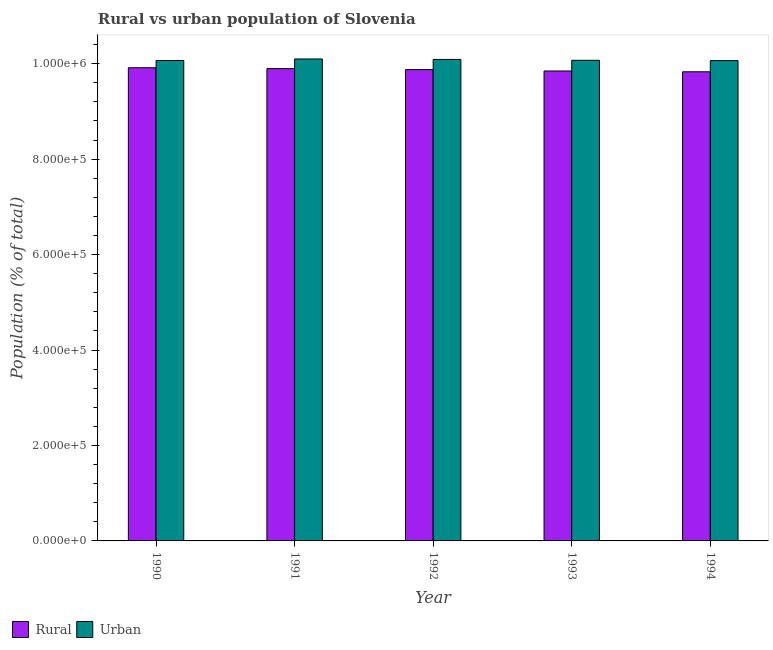How many different coloured bars are there?
Keep it short and to the point. 2. What is the label of the 4th group of bars from the left?
Your response must be concise. 1993. What is the rural population density in 1990?
Offer a terse response. 9.91e+05. Across all years, what is the maximum urban population density?
Give a very brief answer. 1.01e+06. Across all years, what is the minimum urban population density?
Provide a short and direct response. 1.01e+06. In which year was the rural population density maximum?
Offer a terse response. 1990. In which year was the rural population density minimum?
Provide a succinct answer. 1994. What is the total urban population density in the graph?
Your answer should be compact. 5.04e+06. What is the difference between the rural population density in 1991 and that in 1994?
Offer a terse response. 6573. What is the difference between the rural population density in 1992 and the urban population density in 1994?
Ensure brevity in your answer.  4584. What is the average urban population density per year?
Offer a terse response. 1.01e+06. What is the ratio of the urban population density in 1991 to that in 1993?
Give a very brief answer. 1. Is the difference between the rural population density in 1991 and 1994 greater than the difference between the urban population density in 1991 and 1994?
Your answer should be very brief. No. What is the difference between the highest and the second highest urban population density?
Keep it short and to the point. 942. What is the difference between the highest and the lowest rural population density?
Ensure brevity in your answer.  8483. In how many years, is the urban population density greater than the average urban population density taken over all years?
Your answer should be very brief. 2. Is the sum of the rural population density in 1990 and 1994 greater than the maximum urban population density across all years?
Your response must be concise. Yes. What does the 1st bar from the left in 1994 represents?
Offer a very short reply. Rural. What does the 2nd bar from the right in 1994 represents?
Offer a terse response. Rural. Are all the bars in the graph horizontal?
Keep it short and to the point. No. How many years are there in the graph?
Ensure brevity in your answer.  5. What is the difference between two consecutive major ticks on the Y-axis?
Offer a terse response. 2.00e+05. Does the graph contain any zero values?
Your answer should be very brief. No. Does the graph contain grids?
Provide a succinct answer. No. Where does the legend appear in the graph?
Offer a terse response. Bottom left. How are the legend labels stacked?
Ensure brevity in your answer.  Horizontal. What is the title of the graph?
Ensure brevity in your answer.  Rural vs urban population of Slovenia. What is the label or title of the Y-axis?
Provide a succinct answer. Population (% of total). What is the Population (% of total) of Rural in 1990?
Your answer should be compact. 9.91e+05. What is the Population (% of total) of Urban in 1990?
Offer a very short reply. 1.01e+06. What is the Population (% of total) of Rural in 1991?
Offer a terse response. 9.90e+05. What is the Population (% of total) of Urban in 1991?
Provide a succinct answer. 1.01e+06. What is the Population (% of total) in Rural in 1992?
Give a very brief answer. 9.88e+05. What is the Population (% of total) of Urban in 1992?
Ensure brevity in your answer.  1.01e+06. What is the Population (% of total) of Rural in 1993?
Provide a short and direct response. 9.85e+05. What is the Population (% of total) in Urban in 1993?
Your response must be concise. 1.01e+06. What is the Population (% of total) in Rural in 1994?
Your answer should be very brief. 9.83e+05. What is the Population (% of total) of Urban in 1994?
Offer a very short reply. 1.01e+06. Across all years, what is the maximum Population (% of total) of Rural?
Make the answer very short. 9.91e+05. Across all years, what is the maximum Population (% of total) in Urban?
Make the answer very short. 1.01e+06. Across all years, what is the minimum Population (% of total) in Rural?
Offer a terse response. 9.83e+05. Across all years, what is the minimum Population (% of total) in Urban?
Provide a succinct answer. 1.01e+06. What is the total Population (% of total) of Rural in the graph?
Your response must be concise. 4.94e+06. What is the total Population (% of total) of Urban in the graph?
Offer a terse response. 5.04e+06. What is the difference between the Population (% of total) in Rural in 1990 and that in 1991?
Keep it short and to the point. 1910. What is the difference between the Population (% of total) of Urban in 1990 and that in 1991?
Your response must be concise. -3178. What is the difference between the Population (% of total) of Rural in 1990 and that in 1992?
Offer a very short reply. 3899. What is the difference between the Population (% of total) in Urban in 1990 and that in 1992?
Keep it short and to the point. -2236. What is the difference between the Population (% of total) of Rural in 1990 and that in 1993?
Provide a succinct answer. 6788. What is the difference between the Population (% of total) of Urban in 1990 and that in 1993?
Give a very brief answer. -373. What is the difference between the Population (% of total) of Rural in 1990 and that in 1994?
Your answer should be compact. 8483. What is the difference between the Population (% of total) in Urban in 1990 and that in 1994?
Offer a very short reply. 235. What is the difference between the Population (% of total) in Rural in 1991 and that in 1992?
Your answer should be compact. 1989. What is the difference between the Population (% of total) in Urban in 1991 and that in 1992?
Your response must be concise. 942. What is the difference between the Population (% of total) of Rural in 1991 and that in 1993?
Offer a very short reply. 4878. What is the difference between the Population (% of total) of Urban in 1991 and that in 1993?
Your answer should be compact. 2805. What is the difference between the Population (% of total) of Rural in 1991 and that in 1994?
Your response must be concise. 6573. What is the difference between the Population (% of total) of Urban in 1991 and that in 1994?
Your response must be concise. 3413. What is the difference between the Population (% of total) in Rural in 1992 and that in 1993?
Your response must be concise. 2889. What is the difference between the Population (% of total) of Urban in 1992 and that in 1993?
Your answer should be very brief. 1863. What is the difference between the Population (% of total) of Rural in 1992 and that in 1994?
Provide a succinct answer. 4584. What is the difference between the Population (% of total) in Urban in 1992 and that in 1994?
Ensure brevity in your answer.  2471. What is the difference between the Population (% of total) of Rural in 1993 and that in 1994?
Ensure brevity in your answer.  1695. What is the difference between the Population (% of total) of Urban in 1993 and that in 1994?
Provide a succinct answer. 608. What is the difference between the Population (% of total) of Rural in 1990 and the Population (% of total) of Urban in 1991?
Your response must be concise. -1.84e+04. What is the difference between the Population (% of total) of Rural in 1990 and the Population (% of total) of Urban in 1992?
Make the answer very short. -1.74e+04. What is the difference between the Population (% of total) in Rural in 1990 and the Population (% of total) in Urban in 1993?
Your answer should be compact. -1.56e+04. What is the difference between the Population (% of total) in Rural in 1990 and the Population (% of total) in Urban in 1994?
Provide a short and direct response. -1.50e+04. What is the difference between the Population (% of total) of Rural in 1991 and the Population (% of total) of Urban in 1992?
Your answer should be very brief. -1.93e+04. What is the difference between the Population (% of total) in Rural in 1991 and the Population (% of total) in Urban in 1993?
Provide a short and direct response. -1.75e+04. What is the difference between the Population (% of total) of Rural in 1991 and the Population (% of total) of Urban in 1994?
Offer a terse response. -1.69e+04. What is the difference between the Population (% of total) of Rural in 1992 and the Population (% of total) of Urban in 1993?
Make the answer very short. -1.95e+04. What is the difference between the Population (% of total) of Rural in 1992 and the Population (% of total) of Urban in 1994?
Your answer should be very brief. -1.89e+04. What is the difference between the Population (% of total) in Rural in 1993 and the Population (% of total) in Urban in 1994?
Ensure brevity in your answer.  -2.17e+04. What is the average Population (% of total) of Rural per year?
Your response must be concise. 9.87e+05. What is the average Population (% of total) in Urban per year?
Offer a terse response. 1.01e+06. In the year 1990, what is the difference between the Population (% of total) of Rural and Population (% of total) of Urban?
Offer a terse response. -1.52e+04. In the year 1991, what is the difference between the Population (% of total) in Rural and Population (% of total) in Urban?
Your answer should be very brief. -2.03e+04. In the year 1992, what is the difference between the Population (% of total) in Rural and Population (% of total) in Urban?
Make the answer very short. -2.13e+04. In the year 1993, what is the difference between the Population (% of total) in Rural and Population (% of total) in Urban?
Your answer should be very brief. -2.23e+04. In the year 1994, what is the difference between the Population (% of total) in Rural and Population (% of total) in Urban?
Make the answer very short. -2.34e+04. What is the ratio of the Population (% of total) in Rural in 1990 to that in 1991?
Offer a very short reply. 1. What is the ratio of the Population (% of total) of Rural in 1990 to that in 1992?
Offer a very short reply. 1. What is the ratio of the Population (% of total) in Rural in 1990 to that in 1994?
Offer a very short reply. 1.01. What is the ratio of the Population (% of total) of Urban in 1990 to that in 1994?
Your response must be concise. 1. What is the ratio of the Population (% of total) in Rural in 1991 to that in 1992?
Provide a succinct answer. 1. What is the ratio of the Population (% of total) of Urban in 1991 to that in 1992?
Make the answer very short. 1. What is the ratio of the Population (% of total) of Urban in 1991 to that in 1993?
Your response must be concise. 1. What is the ratio of the Population (% of total) of Rural in 1991 to that in 1994?
Offer a terse response. 1.01. What is the ratio of the Population (% of total) of Rural in 1992 to that in 1993?
Offer a terse response. 1. What is the ratio of the Population (% of total) in Rural in 1993 to that in 1994?
Your answer should be compact. 1. What is the ratio of the Population (% of total) of Urban in 1993 to that in 1994?
Give a very brief answer. 1. What is the difference between the highest and the second highest Population (% of total) of Rural?
Make the answer very short. 1910. What is the difference between the highest and the second highest Population (% of total) of Urban?
Provide a succinct answer. 942. What is the difference between the highest and the lowest Population (% of total) in Rural?
Provide a succinct answer. 8483. What is the difference between the highest and the lowest Population (% of total) in Urban?
Provide a short and direct response. 3413. 